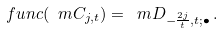<formula> <loc_0><loc_0><loc_500><loc_500>\ f u n c ( \ m C _ { j , t } ) = \ m D _ { - \frac { 2 j } { t } , t ; \bullet } \, .</formula> 